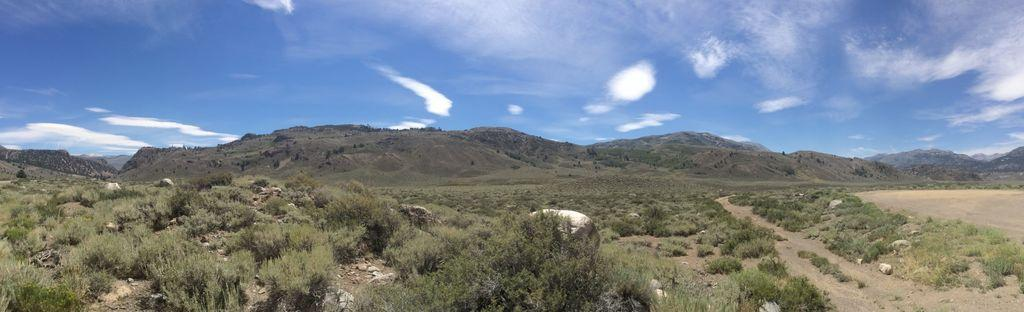What type of natural elements can be seen in the image? There are plants, mountains, and rocks visible in the image. What part of the natural environment is visible in the image? The sky is visible in the image. What type of cord is being used to connect the cars in the image? There are no cars present in the image, so there is no cord connecting any cars. 